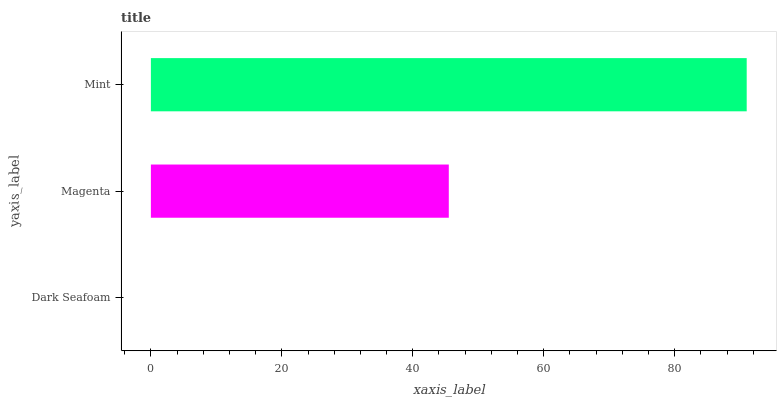Is Dark Seafoam the minimum?
Answer yes or no. Yes. Is Mint the maximum?
Answer yes or no. Yes. Is Magenta the minimum?
Answer yes or no. No. Is Magenta the maximum?
Answer yes or no. No. Is Magenta greater than Dark Seafoam?
Answer yes or no. Yes. Is Dark Seafoam less than Magenta?
Answer yes or no. Yes. Is Dark Seafoam greater than Magenta?
Answer yes or no. No. Is Magenta less than Dark Seafoam?
Answer yes or no. No. Is Magenta the high median?
Answer yes or no. Yes. Is Magenta the low median?
Answer yes or no. Yes. Is Dark Seafoam the high median?
Answer yes or no. No. Is Mint the low median?
Answer yes or no. No. 